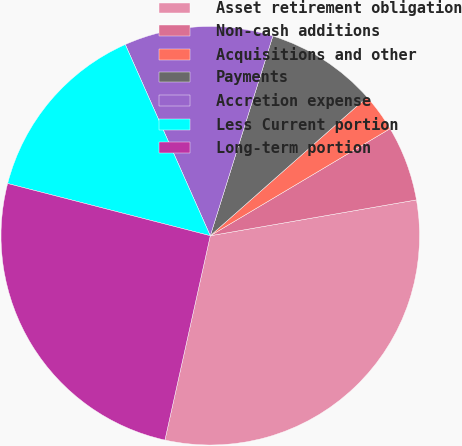Convert chart. <chart><loc_0><loc_0><loc_500><loc_500><pie_chart><fcel>Asset retirement obligation<fcel>Non-cash additions<fcel>Acquisitions and other<fcel>Payments<fcel>Accretion expense<fcel>Less Current portion<fcel>Long-term portion<nl><fcel>31.22%<fcel>5.81%<fcel>2.97%<fcel>8.65%<fcel>11.49%<fcel>14.33%<fcel>25.54%<nl></chart> 